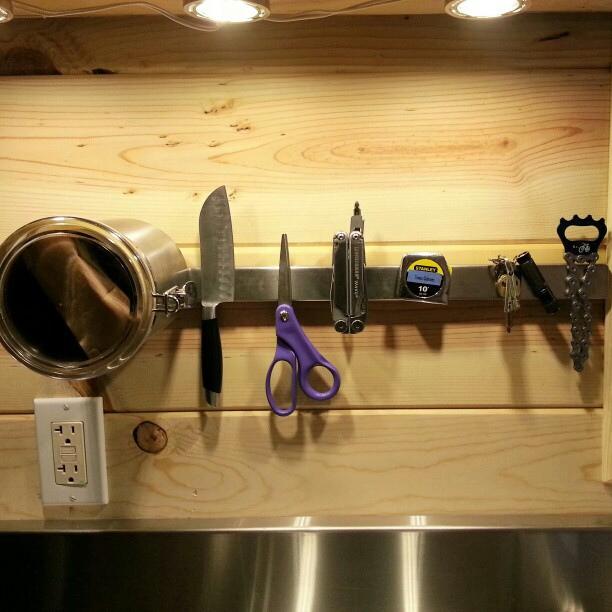What color are the scissor handles?
Keep it brief. Purple. How many knives are on the wall?
Be succinct. 1. Is there a magnet on the wall?
Short answer required. Yes. Why don't these tools fall down?
Be succinct. Magnet. 